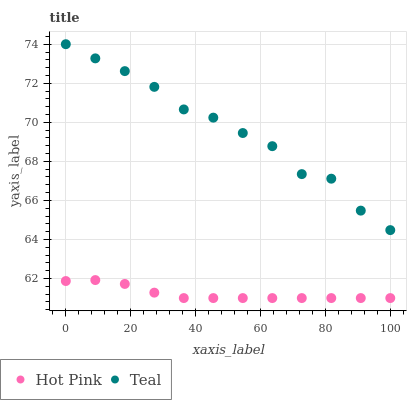Does Hot Pink have the minimum area under the curve?
Answer yes or no. Yes. Does Teal have the maximum area under the curve?
Answer yes or no. Yes. Does Teal have the minimum area under the curve?
Answer yes or no. No. Is Hot Pink the smoothest?
Answer yes or no. Yes. Is Teal the roughest?
Answer yes or no. Yes. Is Teal the smoothest?
Answer yes or no. No. Does Hot Pink have the lowest value?
Answer yes or no. Yes. Does Teal have the lowest value?
Answer yes or no. No. Does Teal have the highest value?
Answer yes or no. Yes. Is Hot Pink less than Teal?
Answer yes or no. Yes. Is Teal greater than Hot Pink?
Answer yes or no. Yes. Does Hot Pink intersect Teal?
Answer yes or no. No. 